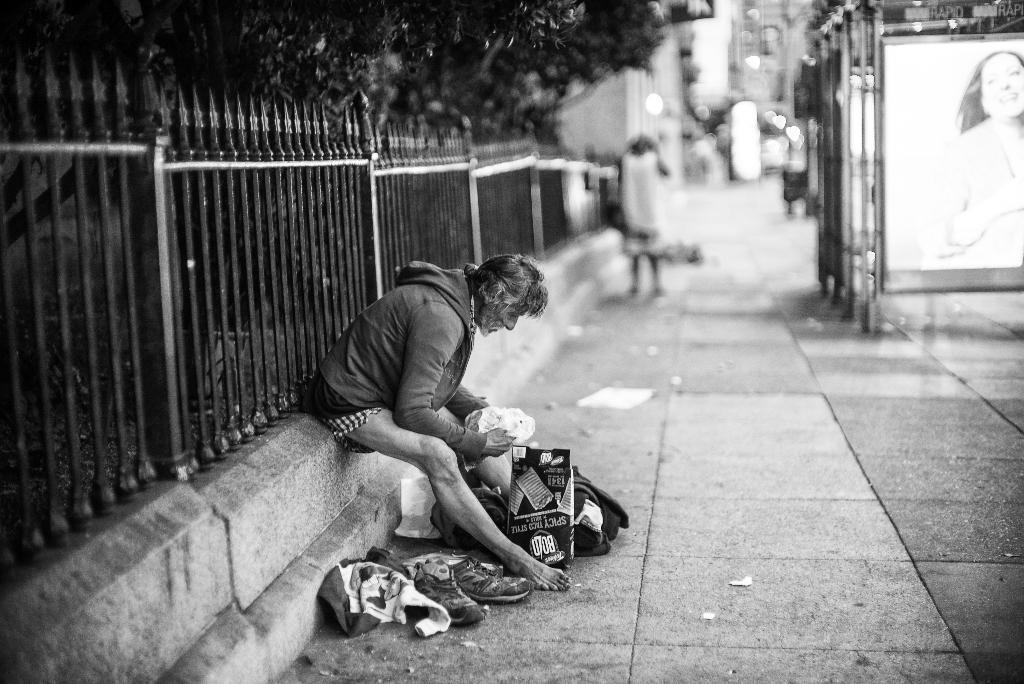Describe this image in one or two sentences. In this image I can see a person sitting. In front of the person I can see few bags, shoes and covers. Background I can see few boards and the other person walking. I can also see trees and the railing and the image is in black and white. 